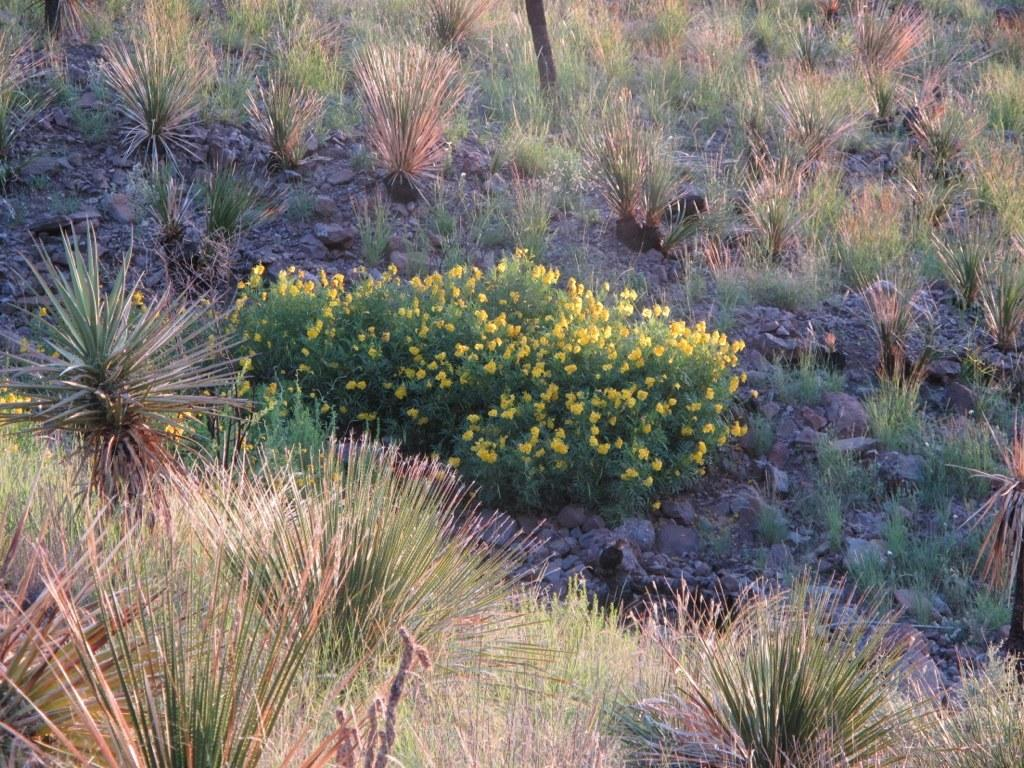What type of plants can be seen in the image? There are flower plants in the image. What other vegetation is present on the ground in the image? There are many bushes on the ground in the image. What type of roof can be seen on the bushes in the image? There is no roof present in the image; it features flower plants and bushes on the ground. What role does the governor play in the image? There is no mention of a governor or any political figure in the image; it focuses on vegetation. 